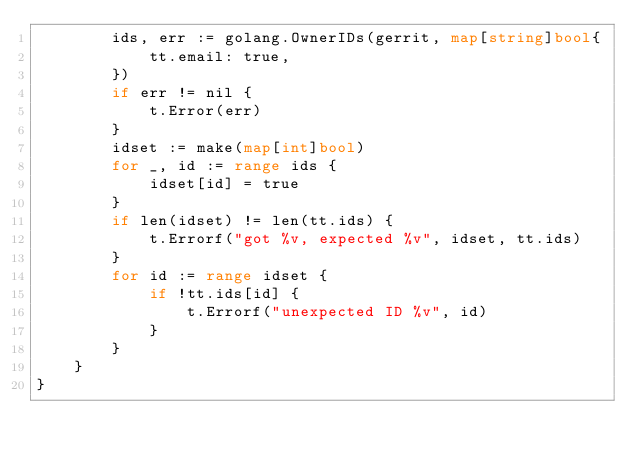<code> <loc_0><loc_0><loc_500><loc_500><_Go_>		ids, err := golang.OwnerIDs(gerrit, map[string]bool{
			tt.email: true,
		})
		if err != nil {
			t.Error(err)
		}
		idset := make(map[int]bool)
		for _, id := range ids {
			idset[id] = true
		}
		if len(idset) != len(tt.ids) {
			t.Errorf("got %v, expected %v", idset, tt.ids)
		}
		for id := range idset {
			if !tt.ids[id] {
				t.Errorf("unexpected ID %v", id)
			}
		}
	}
}
</code> 